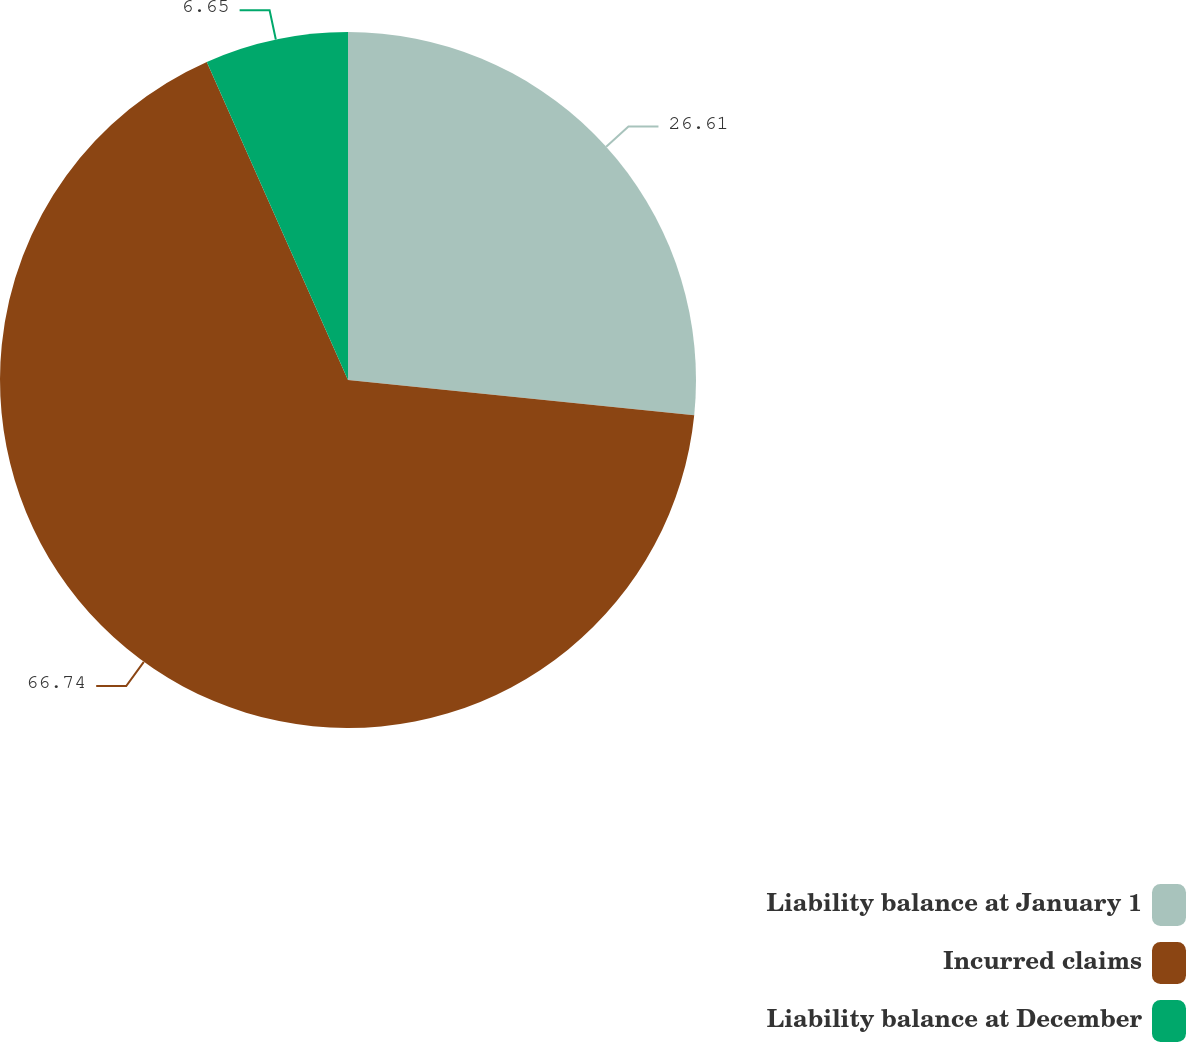Convert chart. <chart><loc_0><loc_0><loc_500><loc_500><pie_chart><fcel>Liability balance at January 1<fcel>Incurred claims<fcel>Liability balance at December<nl><fcel>26.61%<fcel>66.74%<fcel>6.65%<nl></chart> 